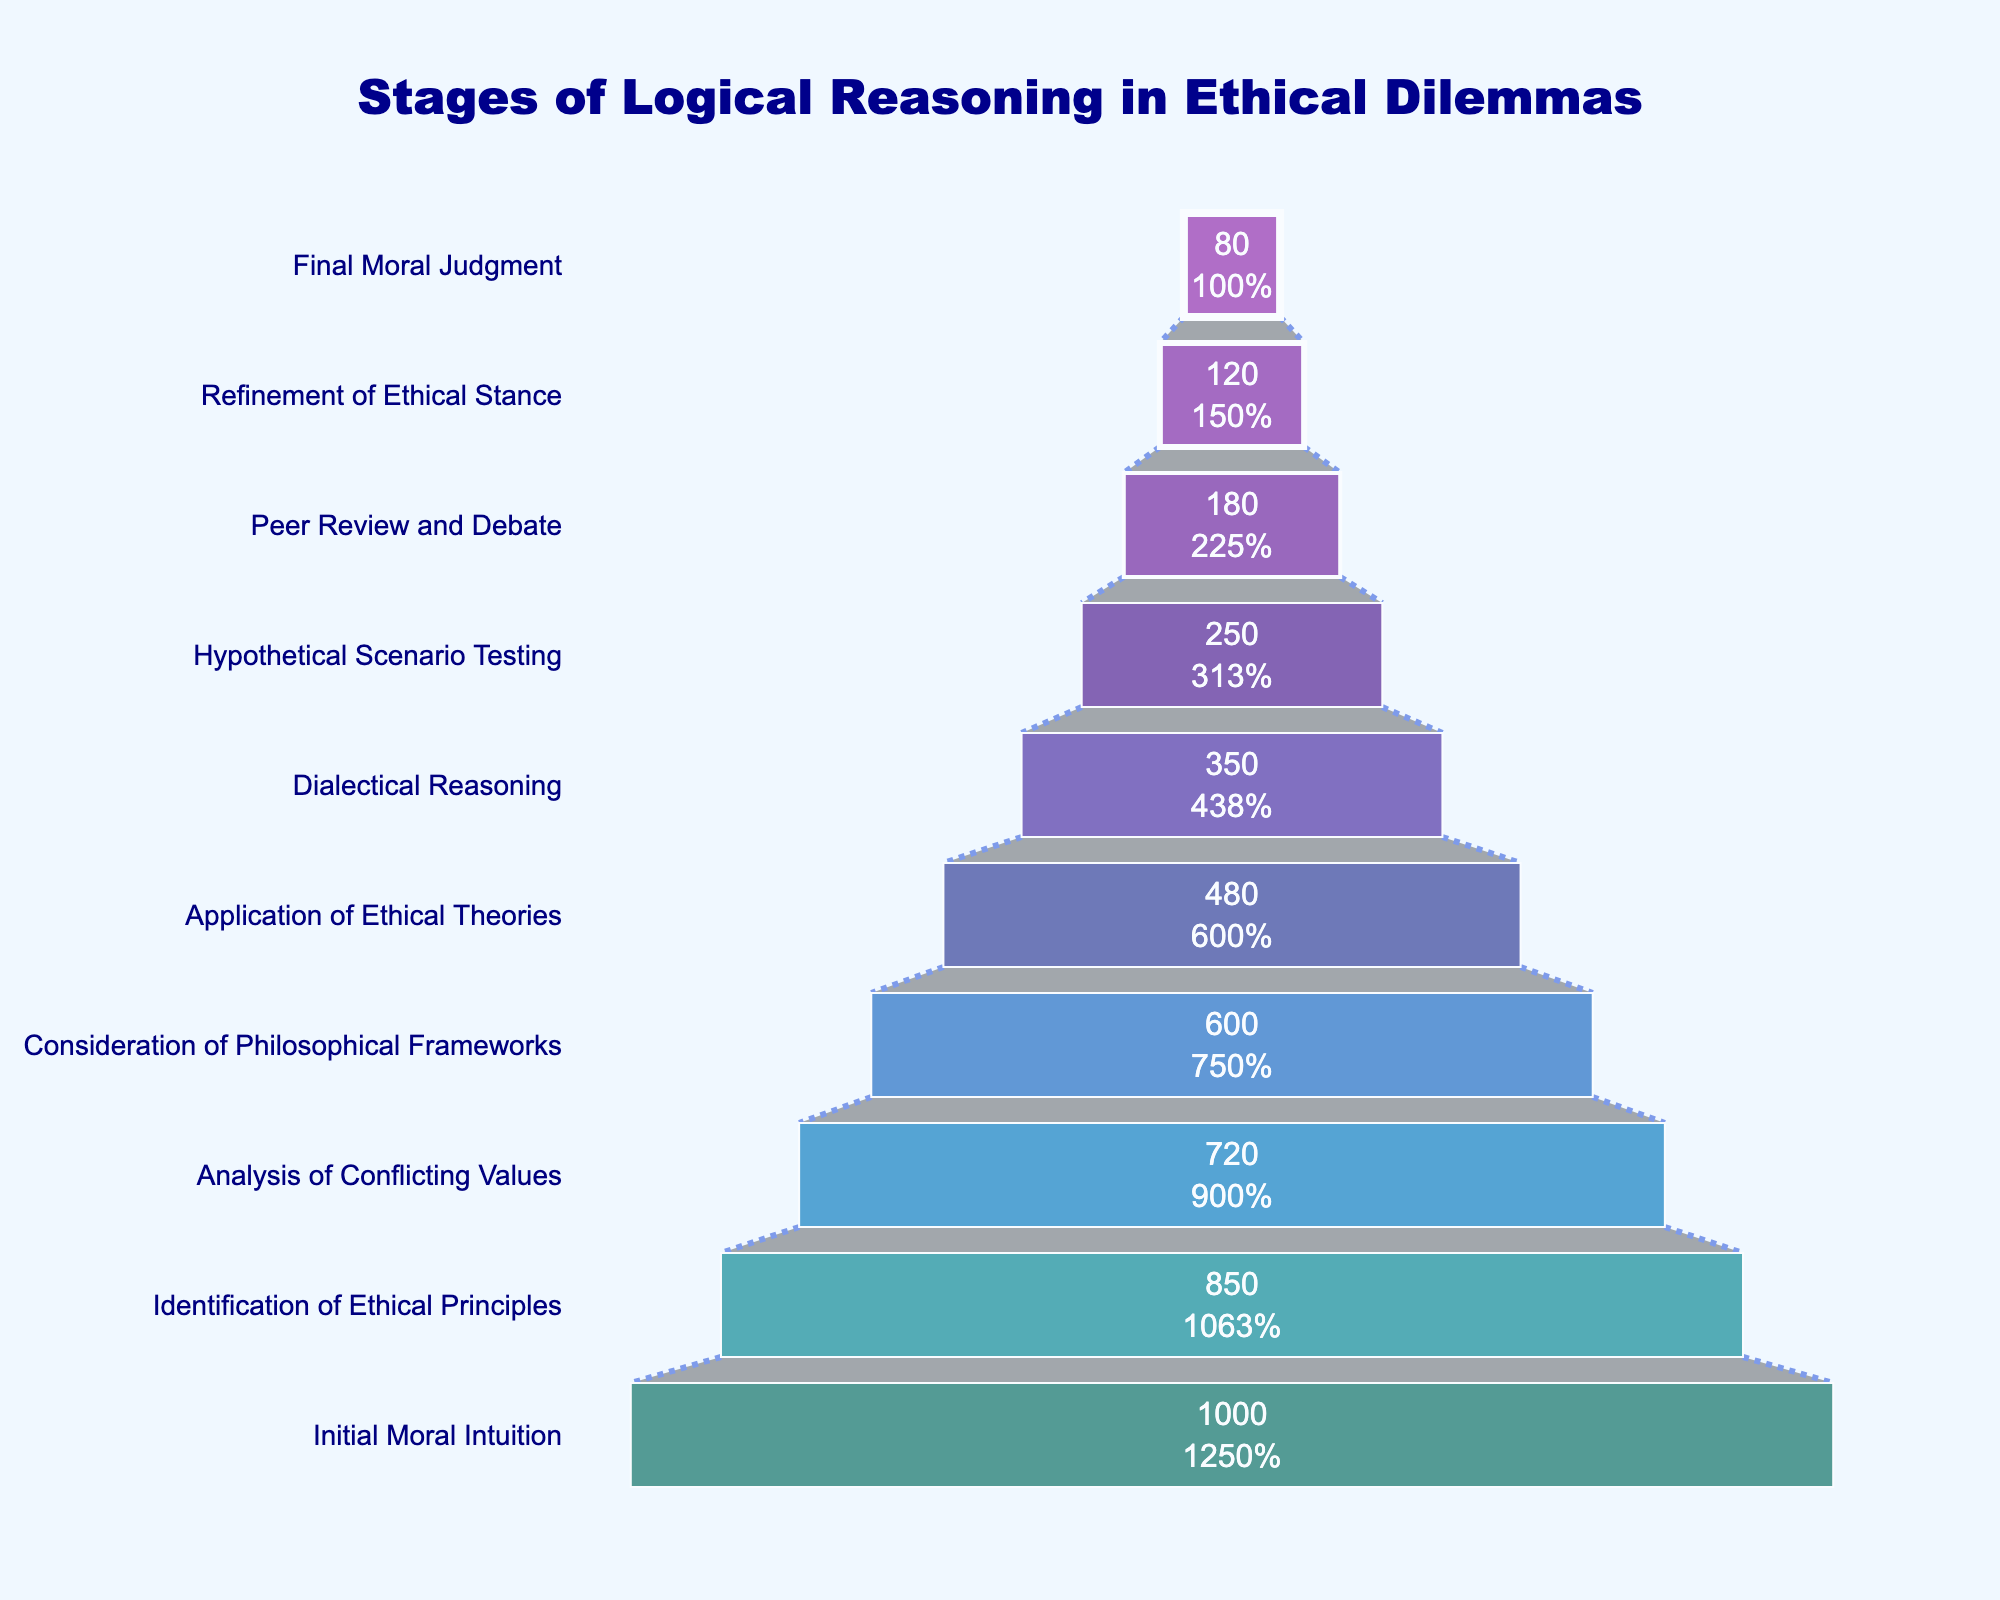What is the title of the figure? The title is usually positioned at the top of the figure and is visually distinct, often larger or bolder than other text elements. In this figure, the title is prominently located at the top center.
Answer: Stages of Logical Reasoning in Ethical Dilemmas Which stage involved the fewest participants? The stage with the fewest participants is represented by the smallest section at the bottom of the funnel chart. It visually stands out as the narrowest part.
Answer: Final Moral Judgment What percentage of participants proceed from the 'Identification of Ethical Principles' stage to the 'Analysis of Conflicting Values' stage? Look at the values or labels inside the funnel chart which show the percentage of participants at each stage in reference to the initial stage. The computation would involve dividing the number of participants at both stages and converting it into a percentage.
Answer: 84.71% What is the difference in the number of participants between 'Initial Moral Intuition' and 'Final Moral Judgment'? The difference is calculated by subtracting the number of participants in the 'Final Moral Judgment' stage from those in the 'Initial Moral Intuition' stage. The numbers are given directly in the figure.
Answer: 920 How many stages have fewer than 500 participants? Count the sections of the funnel chart where the number of participants indicated is less than 500. This involves identifying and counting all relevant funnel sections.
Answer: 5 At which stage does the greatest drop in participants occur? Determine the drop in participants by subtracting the number of participants from one stage to the next, identifying the stages where this difference is the highest. Look for the largest visual gap between consecutive stages.
Answer: Initial Moral Intuition to Identification of Ethical Principles How many color segments are used in the funnel? Observe the number of distinct color sections from top to bottom in the funnel chart. Each stage is typically represented by a different color. This visual observation is straightforward.
Answer: 10 Are there more participants in the 'Dialectical Reasoning' stage or the 'Analysis of Conflicting Values' stage? Compare the participant numbers for both stages directly as annotated inside the funnel chart. Identify which number is higher.
Answer: Analysis of Conflicting Values Describe the trend in participant numbers as stages progress. Visually analyze the funnel chart from top to bottom, noting whether the number of participants increases, decreases, or fluctuates as different stages are listed.
Answer: The number of participants consistently decreases from the top stage to the bottom stage 